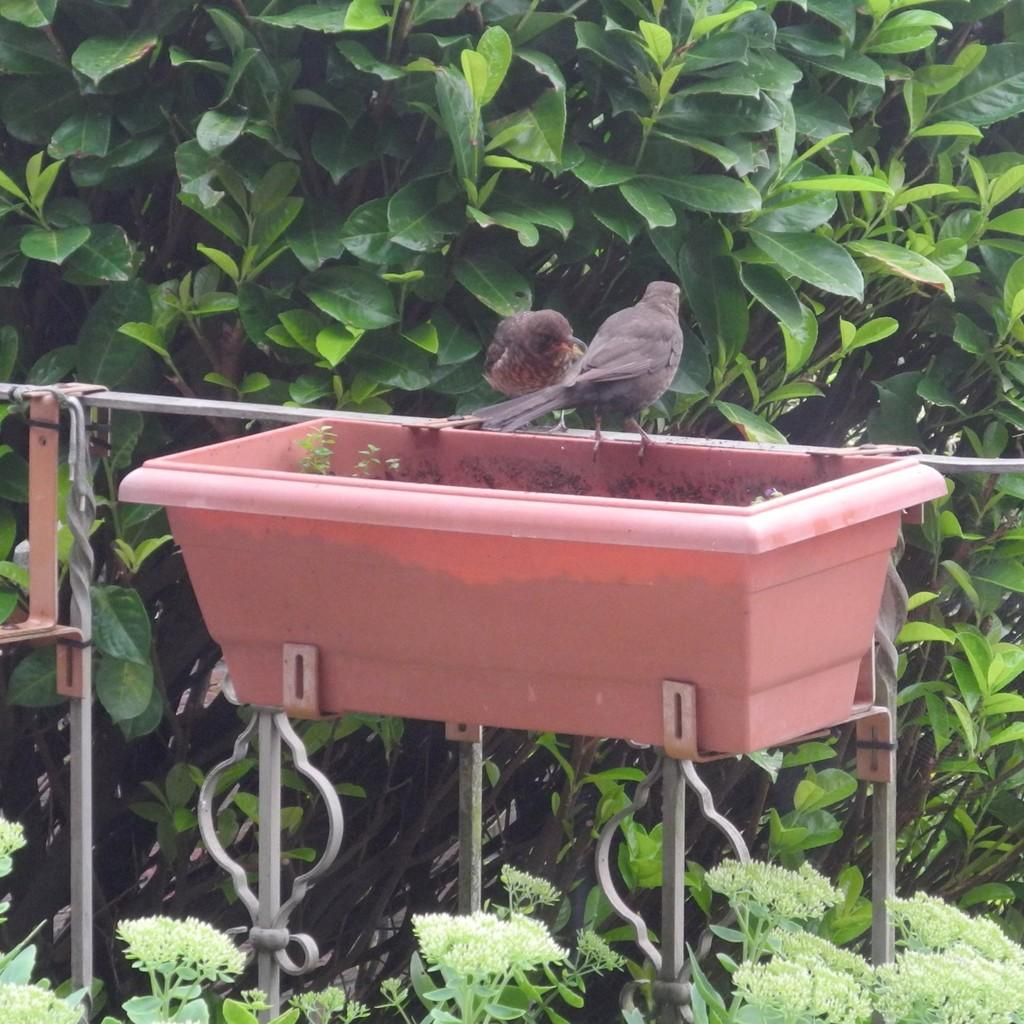What is the color of the basket in the image? The basket in the image is red. How many birds are present in the image? There are 2 birds in the image. What is the color of the birds? The birds are grey in color. What else can be seen in the image besides the basket and birds? There are rods and green leaves on stems visible in the image. What type of mask is the bird wearing in the image? There are no masks present in the image; the birds are not wearing any masks. Is there a guitar visible in the image? No, there is no guitar present in the image. 